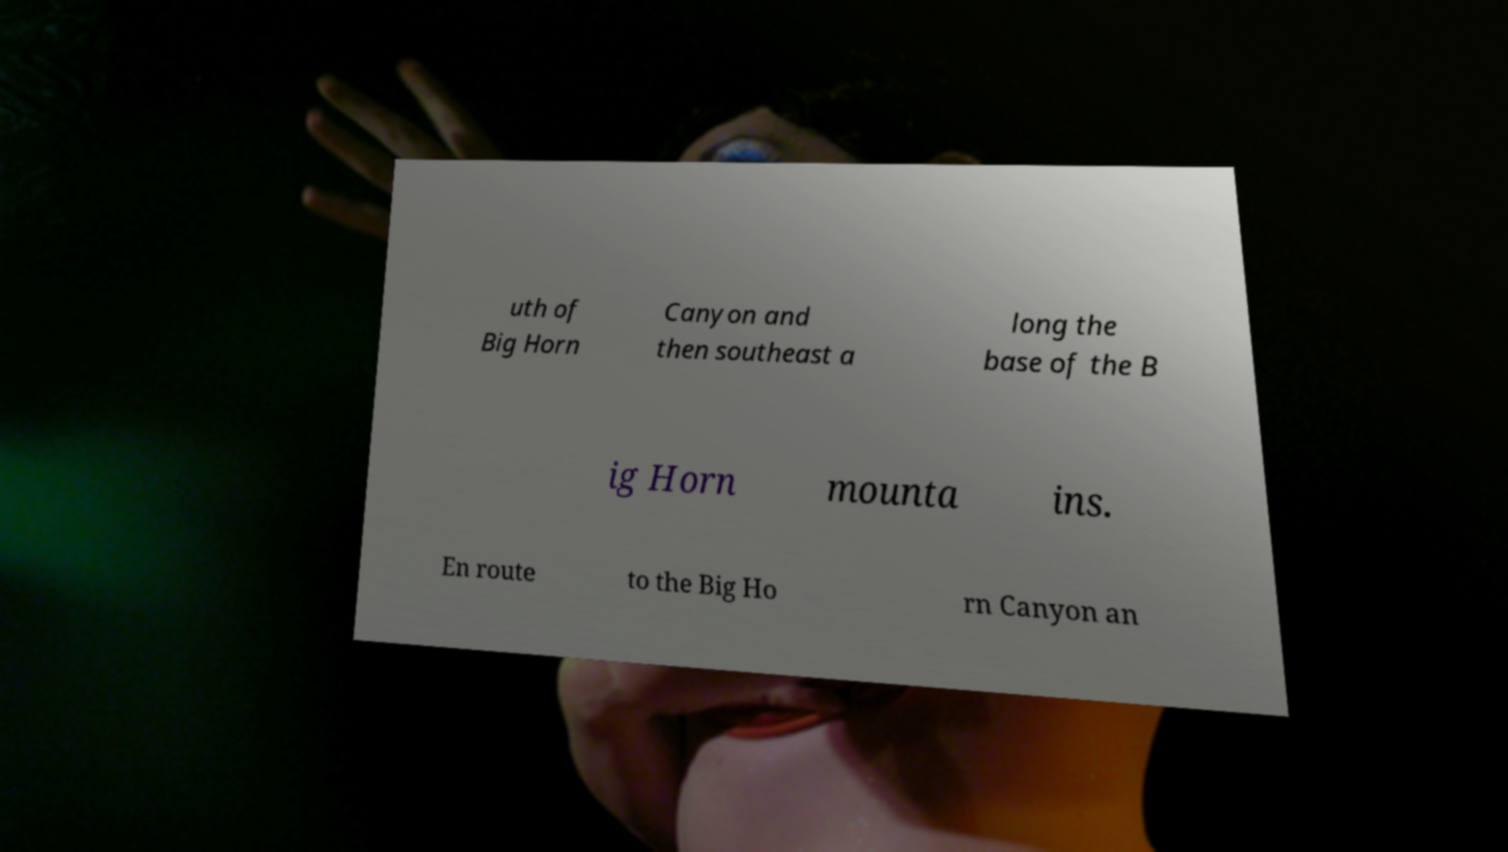There's text embedded in this image that I need extracted. Can you transcribe it verbatim? uth of Big Horn Canyon and then southeast a long the base of the B ig Horn mounta ins. En route to the Big Ho rn Canyon an 